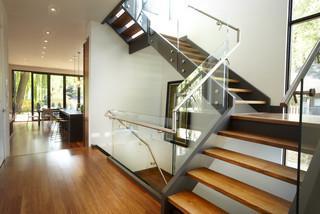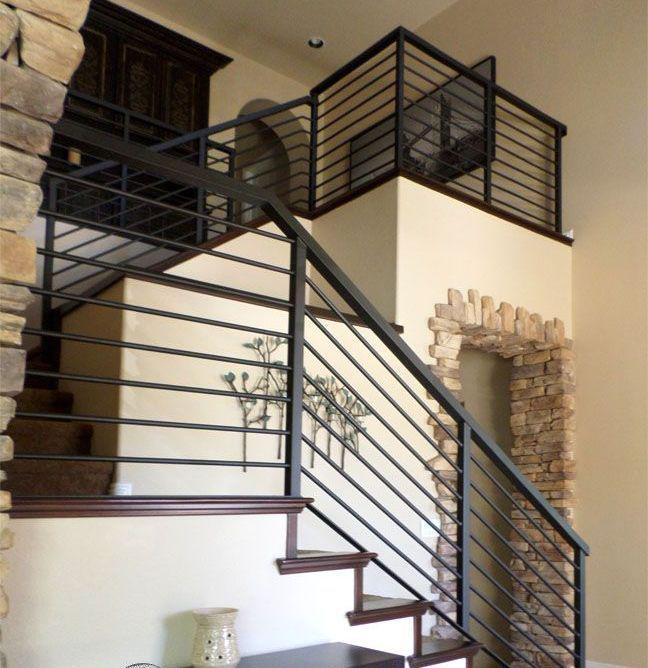The first image is the image on the left, the second image is the image on the right. For the images shown, is this caption "An image shows a staircase with upper landing that combines white paint with brown wood steps and features horizontal metal rails instead of vertical ones." true? Answer yes or no. Yes. The first image is the image on the left, the second image is the image on the right. Examine the images to the left and right. Is the description "One set of stairs heads in just one direction." accurate? Answer yes or no. No. 